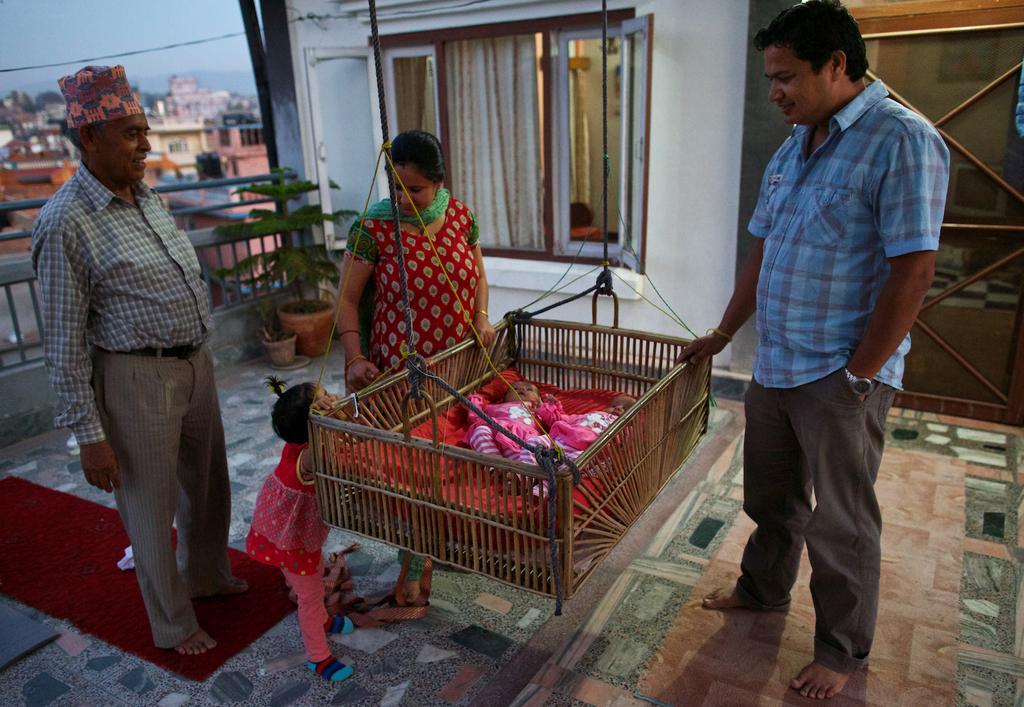Could you give a brief overview of what you see in this image? In this image we can see there are babies in the bay bed. There are people. There is a curtain, windows and a door. There is a carpet. There are house plants. In the background we can see the sky.   